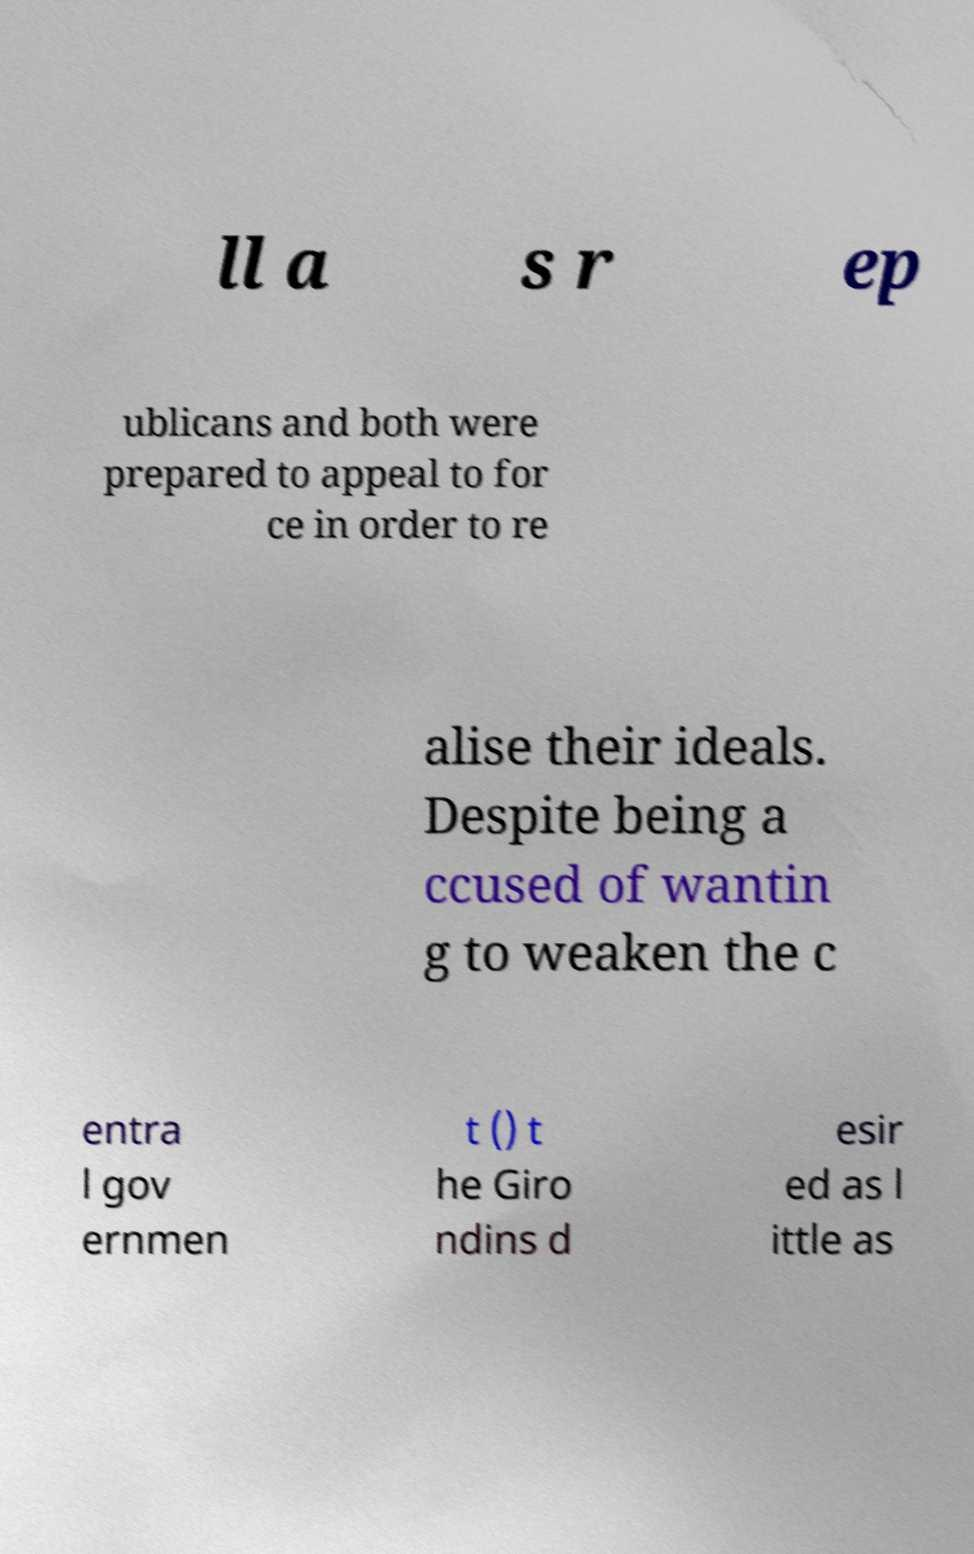Could you assist in decoding the text presented in this image and type it out clearly? ll a s r ep ublicans and both were prepared to appeal to for ce in order to re alise their ideals. Despite being a ccused of wantin g to weaken the c entra l gov ernmen t () t he Giro ndins d esir ed as l ittle as 